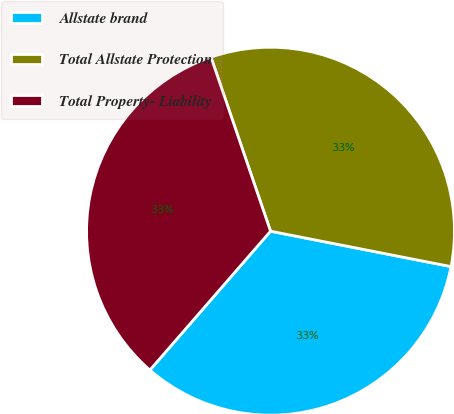Convert chart to OTSL. <chart><loc_0><loc_0><loc_500><loc_500><pie_chart><fcel>Allstate brand<fcel>Total Allstate Protection<fcel>Total Property- Liability<nl><fcel>33.3%<fcel>33.33%<fcel>33.37%<nl></chart> 